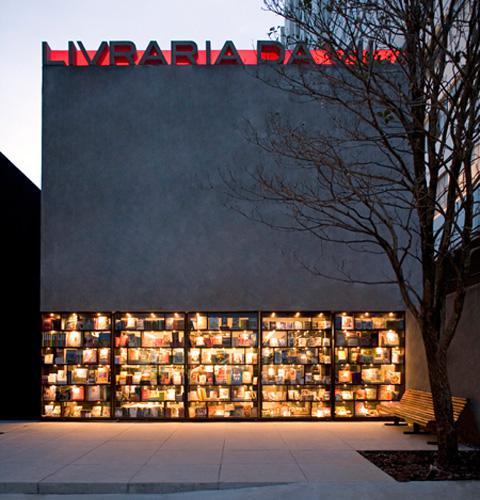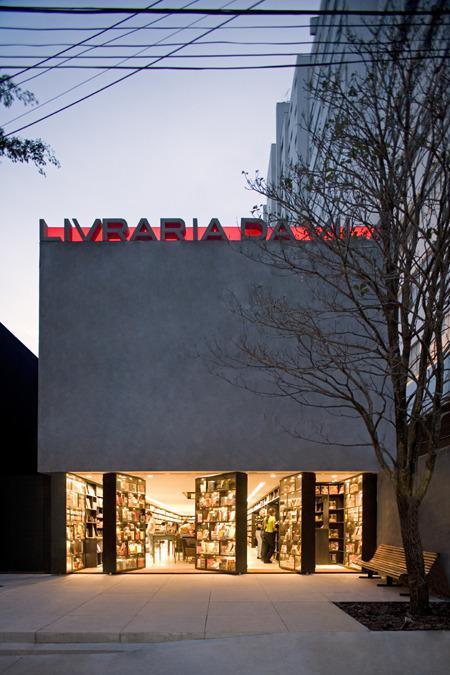The first image is the image on the left, the second image is the image on the right. Given the left and right images, does the statement "The bookstores are all brightly lit up on the inside." hold true? Answer yes or no. Yes. The first image is the image on the left, the second image is the image on the right. Given the left and right images, does the statement "In at least one image there is a brick store with at least three window and a black awning." hold true? Answer yes or no. No. 